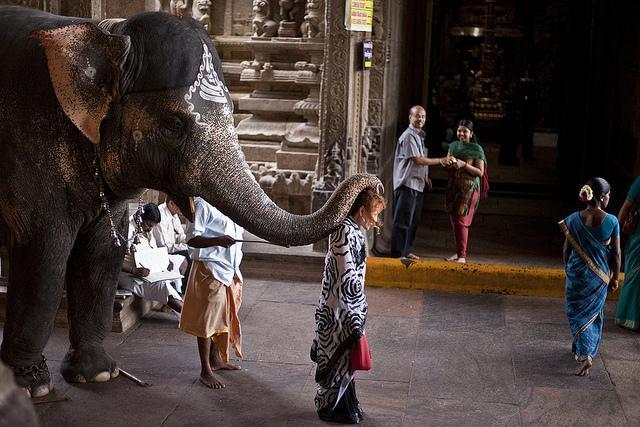How many people are there?
Give a very brief answer. 6. How many sandwiches with orange paste are in the picture?
Give a very brief answer. 0. 